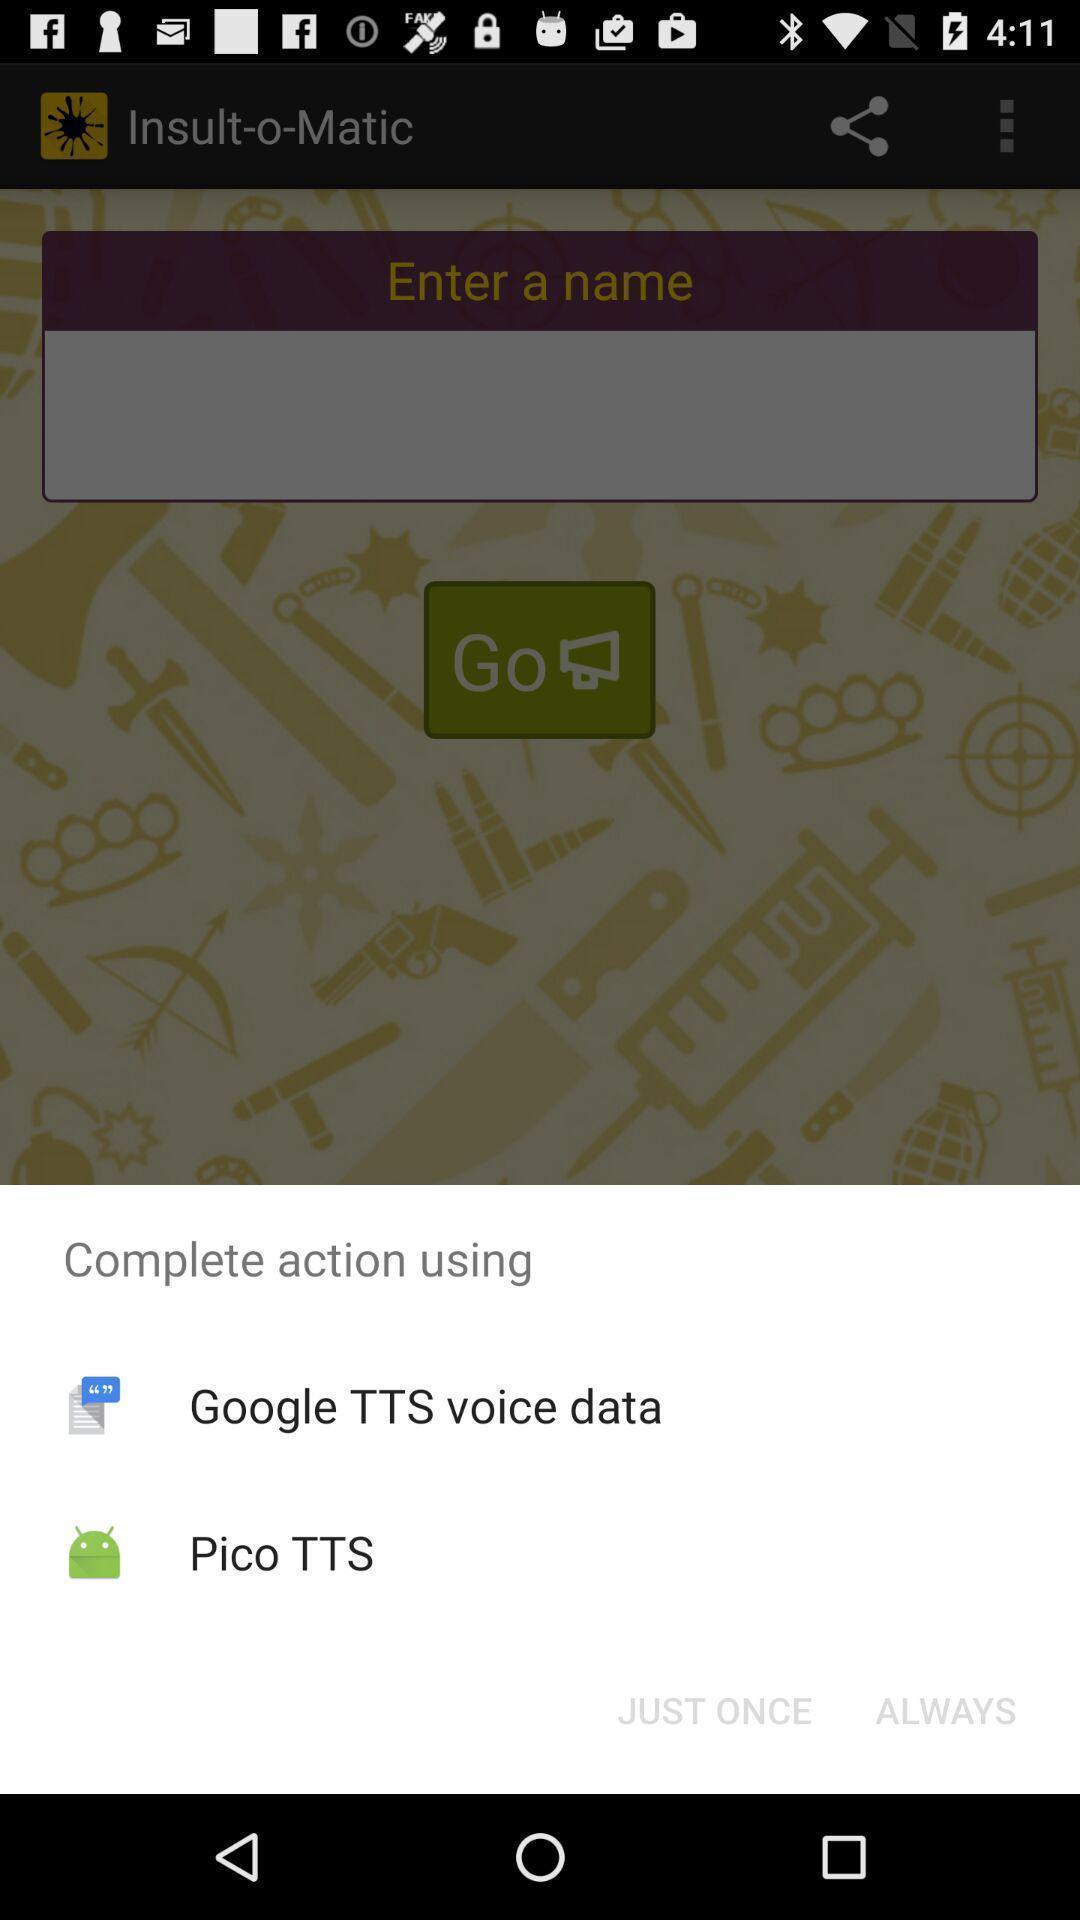Give me a narrative description of this picture. Pop-up widget displaying two text conversion apps. 